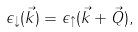Convert formula to latex. <formula><loc_0><loc_0><loc_500><loc_500>\epsilon _ { \downarrow } ( \vec { k } ) = \epsilon _ { \uparrow } ( \vec { k } + \vec { Q } ) ,</formula> 